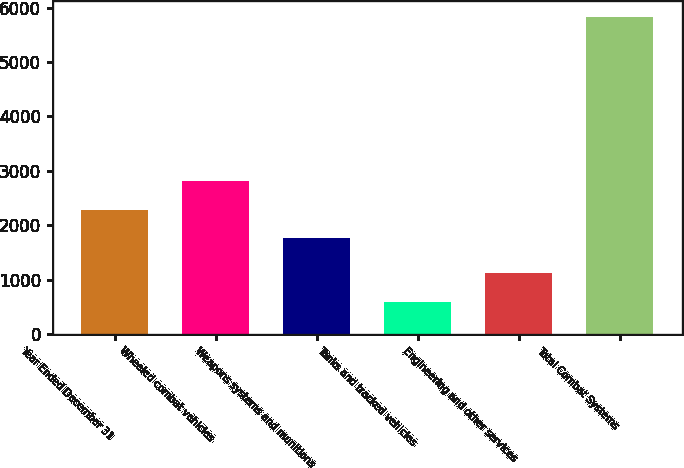Convert chart. <chart><loc_0><loc_0><loc_500><loc_500><bar_chart><fcel>Year Ended December 31<fcel>Wheeled combat vehicles<fcel>Weapons systems and munitions<fcel>Tanks and tracked vehicles<fcel>Engineering and other services<fcel>Total Combat Systems<nl><fcel>2284.7<fcel>2808.4<fcel>1761<fcel>595<fcel>1118.7<fcel>5832<nl></chart> 